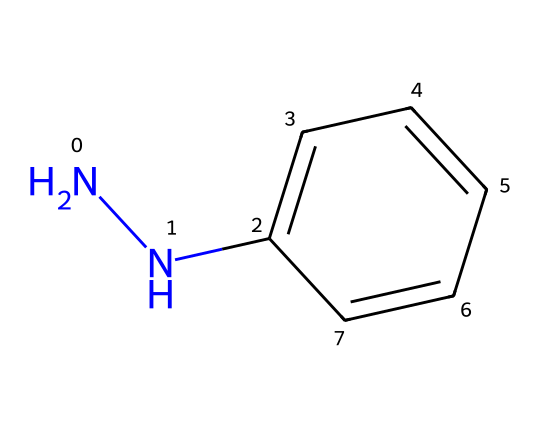What is the molecular formula of phenylhydrazine? By analyzing the SMILES representation (NNC1=CC=CC=C1), we can count the atoms: there are 6 Carbon atoms, 8 Hydrogen atoms, and 2 Nitrogen atoms. Thus, the molecular formula is C6H8N2.
Answer: C6H8N2 How many nitrogen atoms are present in phenylhydrazine? From the SMILES notation (NNC1=CC=CC=C1), we can see two nitrogen atoms at the beginning (NNC).
Answer: 2 What type of chemical is phenylhydrazine? Phenylhydrazine is categorized as a hydrazine due to the presence of the hydrazine (-N-N-) functional group in its structure.
Answer: hydrazine What effect does phenylhydrazine have on coffee bean preservation? Phenylhydrazine can act as an antioxidant, potentially reducing oxidative spoilage in coffee beans, which aids in preservation.
Answer: antioxidant Does phenylhydrazine have any antimicrobial properties? Due to its chemical structure and the presence of nitrogen, phenylhydrazine has been studied for its potential antimicrobial effects against certain microorganisms.
Answer: antimicrobial How many rings are present in the structure of phenylhydrazine? The SMILES notation indicates a benzene ring in C1=CC=CC=C1, thus there is one ring in the structure of phenylhydrazine.
Answer: 1 